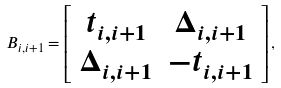Convert formula to latex. <formula><loc_0><loc_0><loc_500><loc_500>B _ { i , i + 1 } = \left [ \begin{array} { c c } t _ { i , i + 1 } & \Delta _ { i , i + 1 } \\ \Delta _ { i , i + 1 } & - t _ { i , i + 1 } \end{array} \right ] ,</formula> 